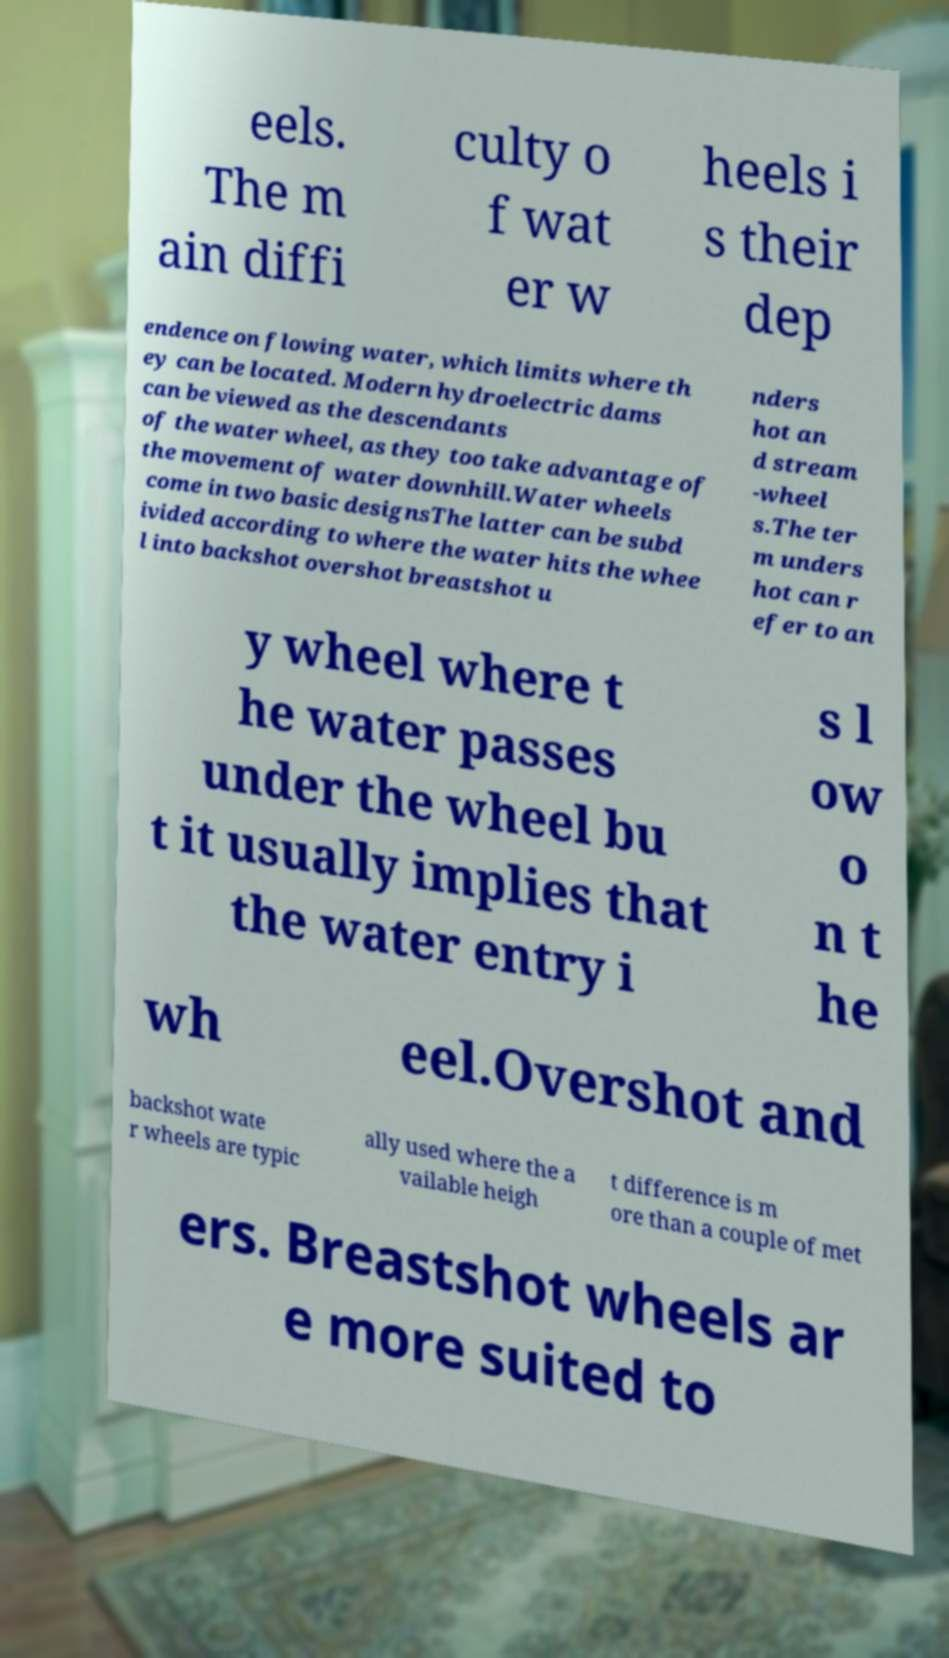What messages or text are displayed in this image? I need them in a readable, typed format. eels. The m ain diffi culty o f wat er w heels i s their dep endence on flowing water, which limits where th ey can be located. Modern hydroelectric dams can be viewed as the descendants of the water wheel, as they too take advantage of the movement of water downhill.Water wheels come in two basic designsThe latter can be subd ivided according to where the water hits the whee l into backshot overshot breastshot u nders hot an d stream -wheel s.The ter m unders hot can r efer to an y wheel where t he water passes under the wheel bu t it usually implies that the water entry i s l ow o n t he wh eel.Overshot and backshot wate r wheels are typic ally used where the a vailable heigh t difference is m ore than a couple of met ers. Breastshot wheels ar e more suited to 